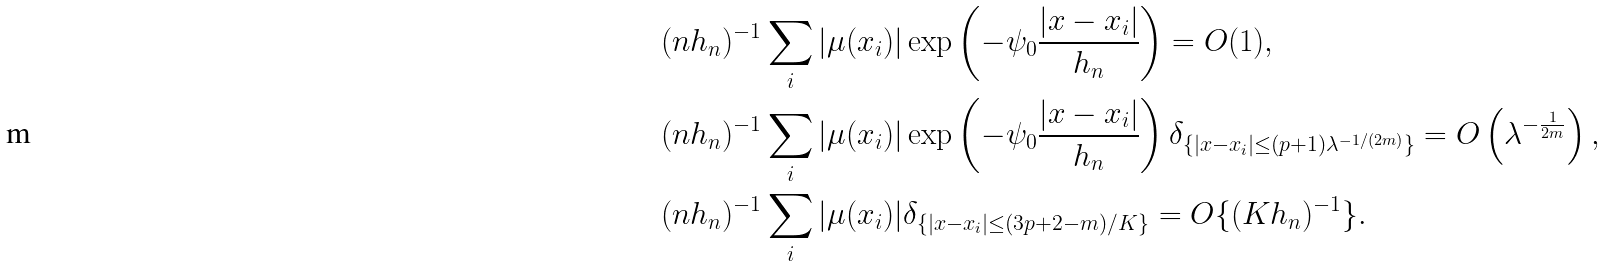<formula> <loc_0><loc_0><loc_500><loc_500>& ( n h _ { n } ) ^ { - 1 } \sum _ { i } | \mu ( x _ { i } ) | \exp \left ( - \psi _ { 0 } \frac { | x - x _ { i } | } { h _ { n } } \right ) = O ( 1 ) , \\ & ( n h _ { n } ) ^ { - 1 } \sum _ { i } | \mu ( x _ { i } ) | \exp \left ( - \psi _ { 0 } \frac { | x - x _ { i } | } { h _ { n } } \right ) \delta _ { \{ | x - x _ { i } | \leq ( p + 1 ) \lambda ^ { - 1 / ( 2 m ) } \} } = O \left ( \lambda ^ { - \frac { 1 } { 2 m } } \right ) , \\ & ( n h _ { n } ) ^ { - 1 } \sum _ { i } | \mu ( x _ { i } ) | \delta _ { \{ | x - x _ { i } | \leq ( 3 p + 2 - m ) / K \} } = O \{ ( K h _ { n } ) ^ { - 1 } \} .</formula> 